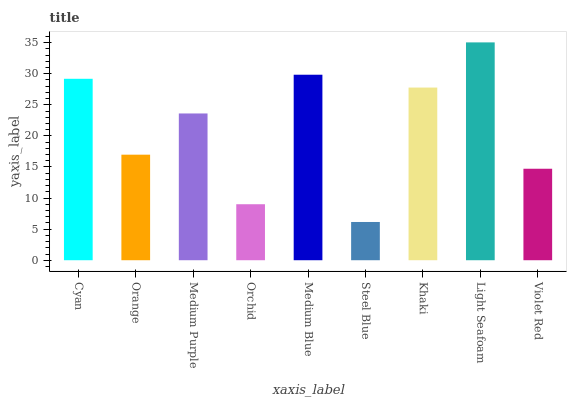Is Steel Blue the minimum?
Answer yes or no. Yes. Is Light Seafoam the maximum?
Answer yes or no. Yes. Is Orange the minimum?
Answer yes or no. No. Is Orange the maximum?
Answer yes or no. No. Is Cyan greater than Orange?
Answer yes or no. Yes. Is Orange less than Cyan?
Answer yes or no. Yes. Is Orange greater than Cyan?
Answer yes or no. No. Is Cyan less than Orange?
Answer yes or no. No. Is Medium Purple the high median?
Answer yes or no. Yes. Is Medium Purple the low median?
Answer yes or no. Yes. Is Steel Blue the high median?
Answer yes or no. No. Is Violet Red the low median?
Answer yes or no. No. 